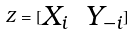Convert formula to latex. <formula><loc_0><loc_0><loc_500><loc_500>Z = [ \begin{matrix} X _ { i } & Y _ { - i } \end{matrix} ]</formula> 